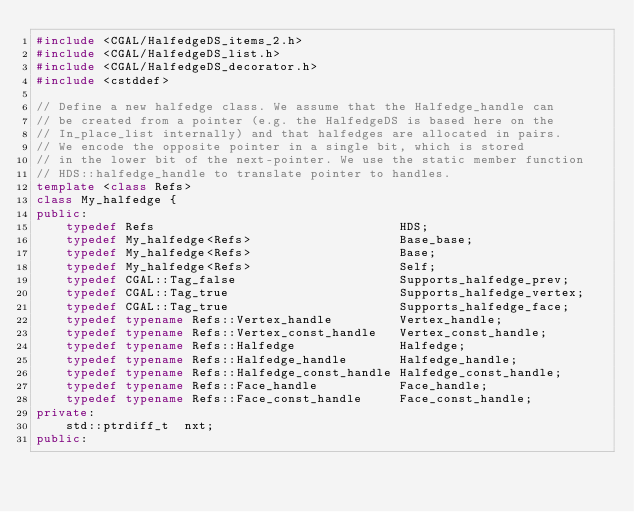<code> <loc_0><loc_0><loc_500><loc_500><_C++_>#include <CGAL/HalfedgeDS_items_2.h>
#include <CGAL/HalfedgeDS_list.h>
#include <CGAL/HalfedgeDS_decorator.h>
#include <cstddef>

// Define a new halfedge class. We assume that the Halfedge_handle can
// be created from a pointer (e.g. the HalfedgeDS is based here on the
// In_place_list internally) and that halfedges are allocated in pairs.
// We encode the opposite pointer in a single bit, which is stored
// in the lower bit of the next-pointer. We use the static member function
// HDS::halfedge_handle to translate pointer to handles.
template <class Refs>
class My_halfedge {
public:
    typedef Refs                                 HDS;
    typedef My_halfedge<Refs>                    Base_base;
    typedef My_halfedge<Refs>                    Base;
    typedef My_halfedge<Refs>                    Self;
    typedef CGAL::Tag_false                      Supports_halfedge_prev;
    typedef CGAL::Tag_true                       Supports_halfedge_vertex;
    typedef CGAL::Tag_true                       Supports_halfedge_face;
    typedef typename Refs::Vertex_handle         Vertex_handle;
    typedef typename Refs::Vertex_const_handle   Vertex_const_handle;
    typedef typename Refs::Halfedge              Halfedge;
    typedef typename Refs::Halfedge_handle       Halfedge_handle;
    typedef typename Refs::Halfedge_const_handle Halfedge_const_handle;
    typedef typename Refs::Face_handle           Face_handle;
    typedef typename Refs::Face_const_handle     Face_const_handle;
private:
    std::ptrdiff_t  nxt;
public:</code> 